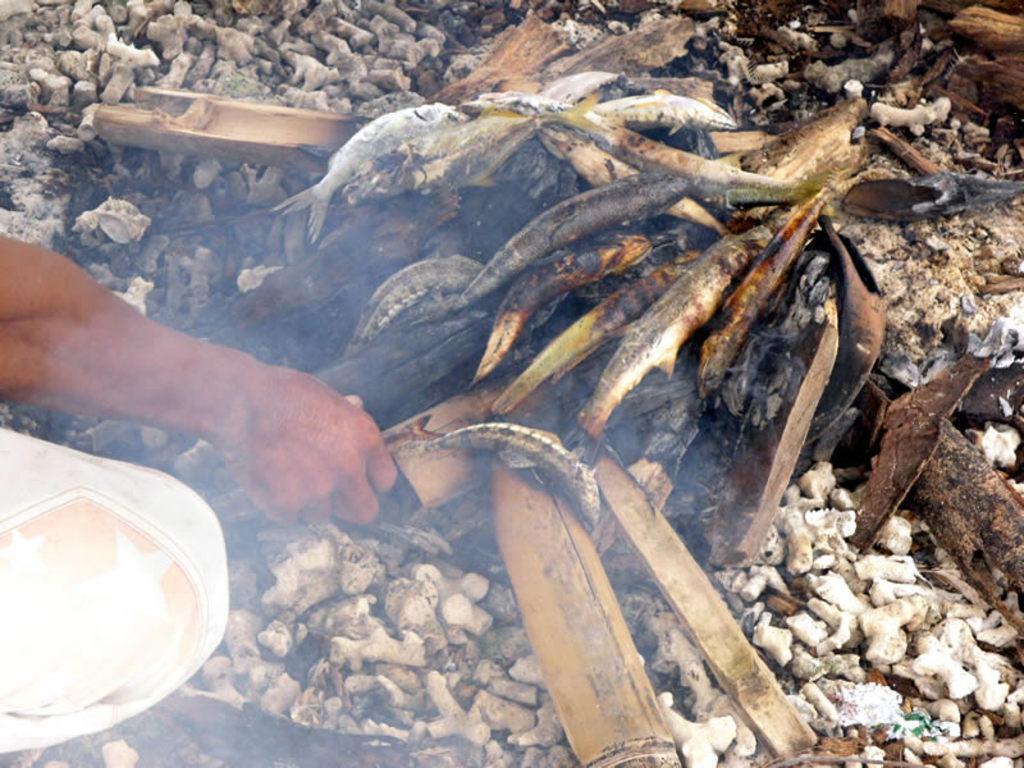In one or two sentences, can you explain what this image depicts? In this image we can see a person cooking fish on bamboo sticks. 